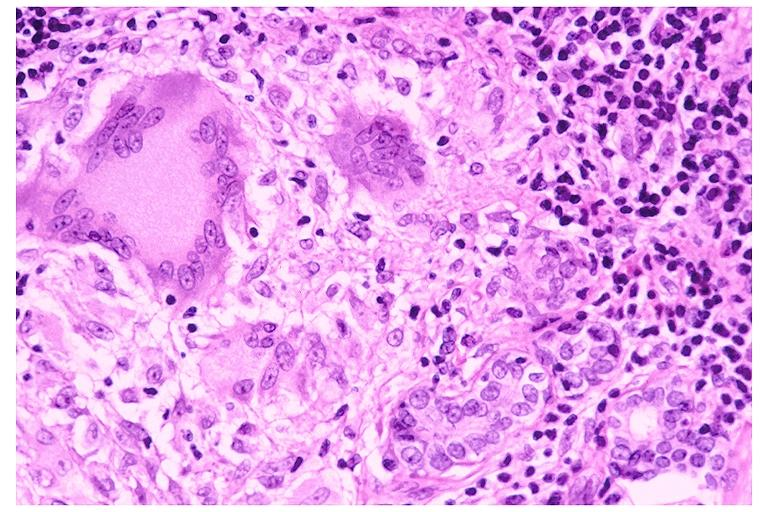what is present?
Answer the question using a single word or phrase. Oral 